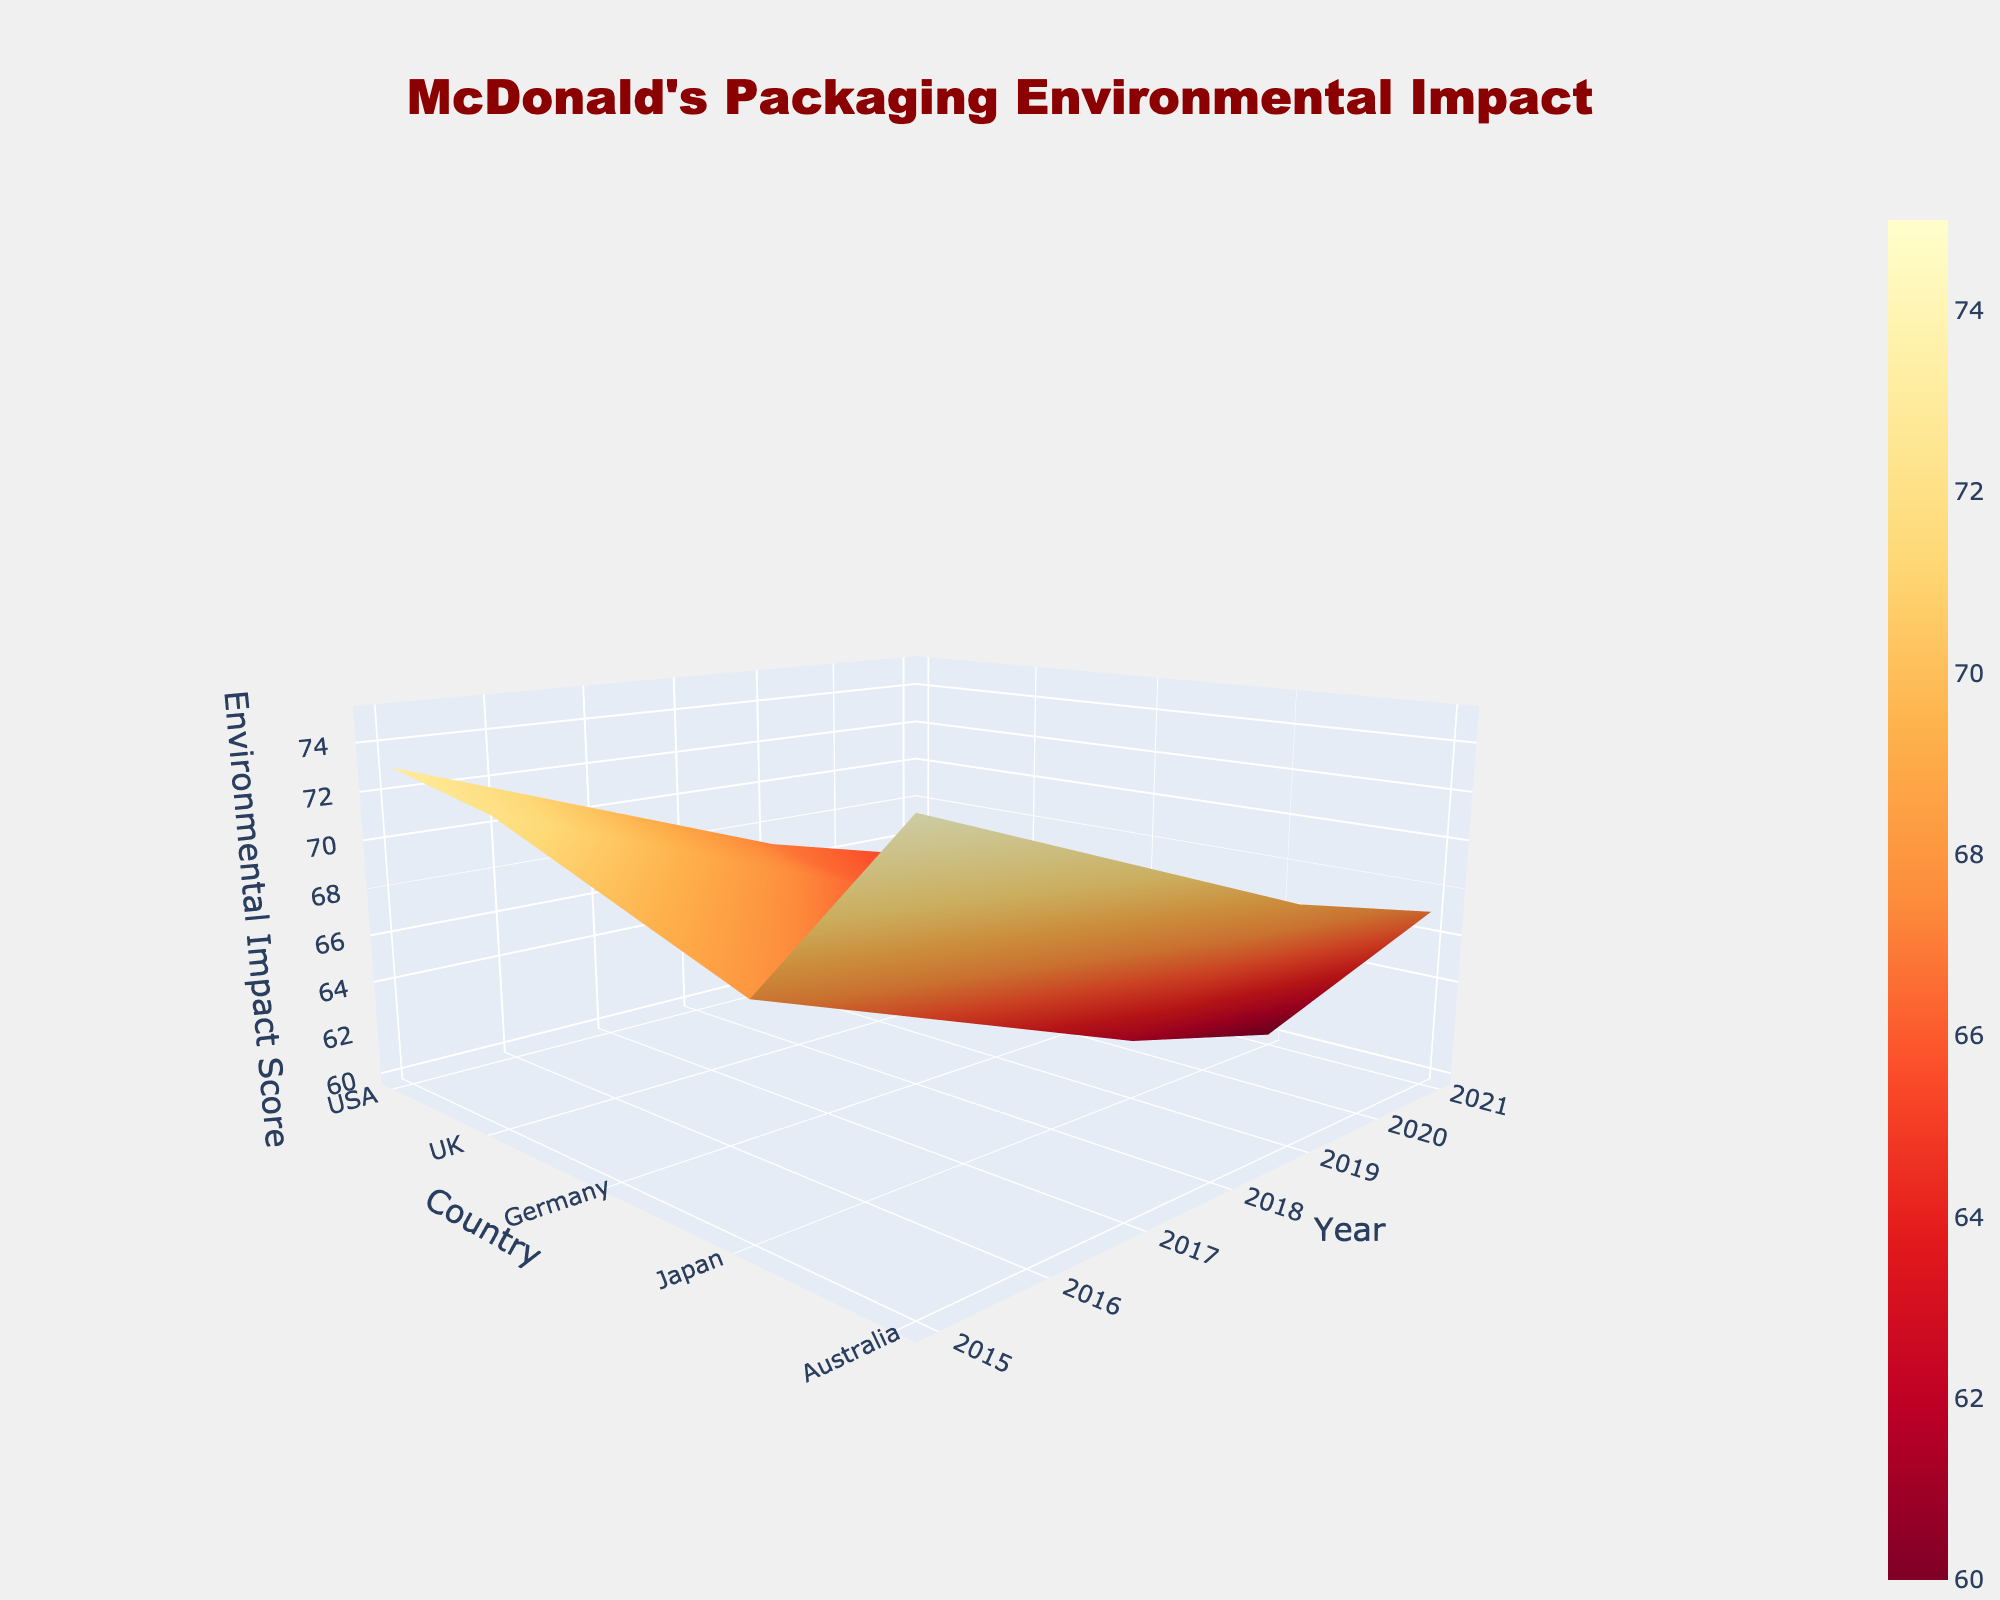What is the title of the 3D surface plot? The title can be found at the top of the plot. It is usually the most prominent text in the figure.
Answer: McDonald's Packaging Environmental Impact What is the range of years displayed on the y-axis? To determine the range of years, look at the labels on the y-axis of the plot.
Answer: 2015 to 2021 What country has the highest Environmental Impact Score in 2015? Identify the score for each country in 2015 and find the highest value.
Answer: USA Which country shows a continuous decline in the Environmental Impact Score from 2015 to 2021? Observe the trend for each country over the years and identify any country with a consistently decreasing score.
Answer: UK Which year shows the overall lowest Environmental Impact Scores across all countries? Compare the scores for every country within each year and determine which year has the lowest overall impact.
Answer: 2021 What is the average Environmental Impact Score for Australia from 2015 to 2021? Sum the scores for Australia over the given years and divide by the number of years (5).
Answer: (73 + 70 + 67 + 65) / 5 = 67 Which country's Environmental Impact Score decreased the most from 2015 to 2021? Calculate the difference in scores between 2015 and 2021 for each country and identify the highest decrease.
Answer: UK Compare the Environmental Impact Scores for Germany and Japan in 2019. Which country had a higher score, and by how much? Check the scores for both Germany and Japan in 2019 and determine the difference.
Answer: Germany had a higher score by 2 Identify the trend in the Environmental Impact Score for the USA from 2015 to 2021. Observe the scores for the USA over the years and describe whether it is increasing, decreasing, or staying the same.
Answer: Decreasing What is the difference between the Environmental Impact Scores of the USA and UK in 2021? Subtract the UK score from the USA score for 2021 to find the difference.
Answer: 67 - 60 = 7 